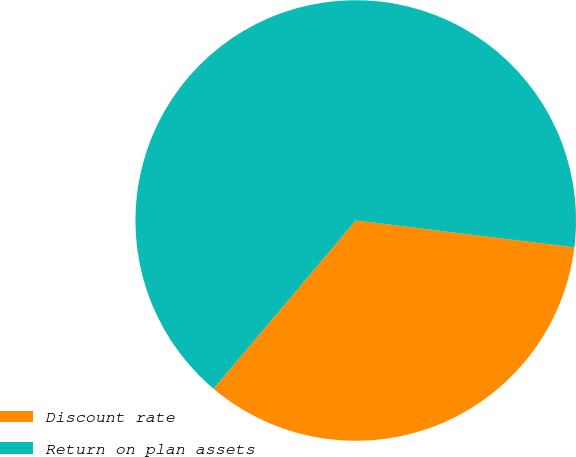<chart> <loc_0><loc_0><loc_500><loc_500><pie_chart><fcel>Discount rate<fcel>Return on plan assets<nl><fcel>34.22%<fcel>65.78%<nl></chart> 